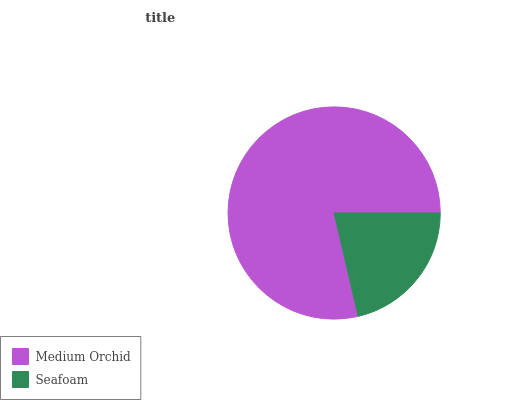Is Seafoam the minimum?
Answer yes or no. Yes. Is Medium Orchid the maximum?
Answer yes or no. Yes. Is Seafoam the maximum?
Answer yes or no. No. Is Medium Orchid greater than Seafoam?
Answer yes or no. Yes. Is Seafoam less than Medium Orchid?
Answer yes or no. Yes. Is Seafoam greater than Medium Orchid?
Answer yes or no. No. Is Medium Orchid less than Seafoam?
Answer yes or no. No. Is Medium Orchid the high median?
Answer yes or no. Yes. Is Seafoam the low median?
Answer yes or no. Yes. Is Seafoam the high median?
Answer yes or no. No. Is Medium Orchid the low median?
Answer yes or no. No. 